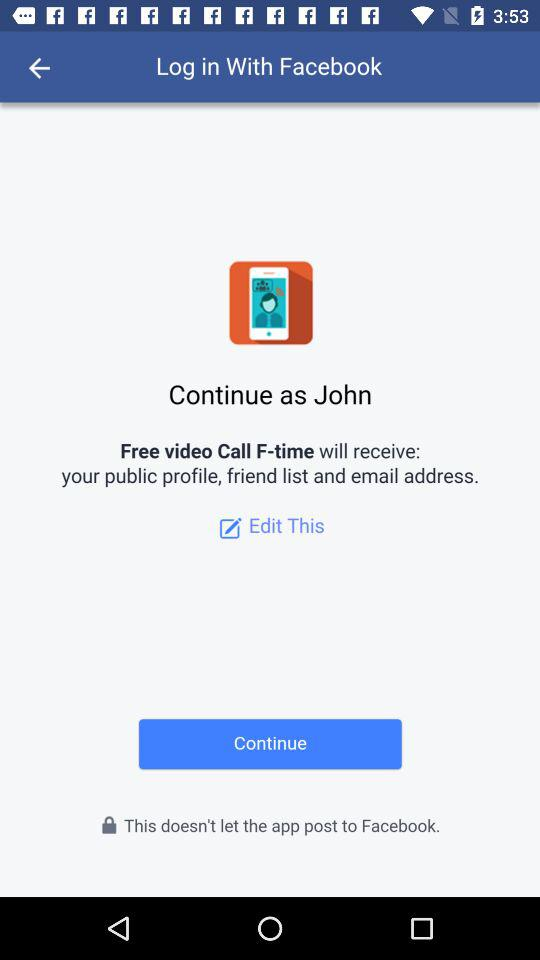What is the name of the user? The name of the user is John. 